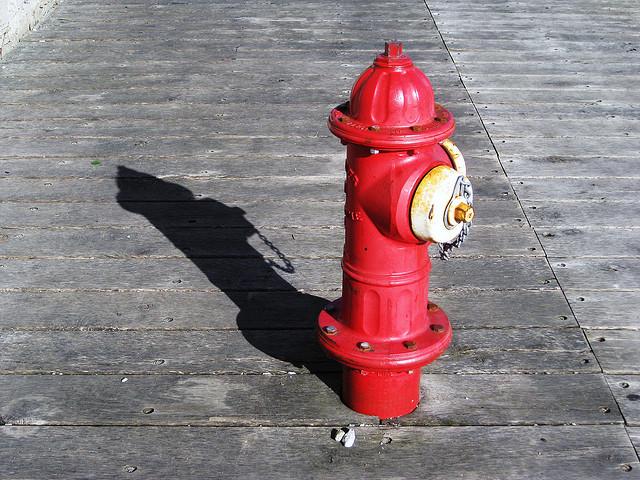What does the red hydrant contain?
Answer briefly. Water. What do we call this kind of walkway?
Write a very short answer. Boardwalk. What would this object be used for?
Short answer required. Fires. 